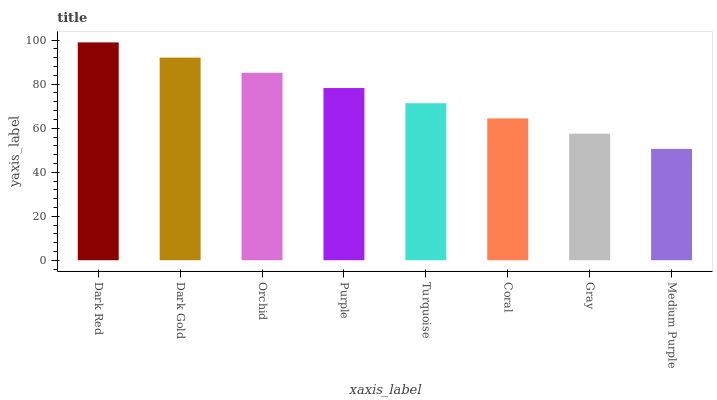Is Medium Purple the minimum?
Answer yes or no. Yes. Is Dark Red the maximum?
Answer yes or no. Yes. Is Dark Gold the minimum?
Answer yes or no. No. Is Dark Gold the maximum?
Answer yes or no. No. Is Dark Red greater than Dark Gold?
Answer yes or no. Yes. Is Dark Gold less than Dark Red?
Answer yes or no. Yes. Is Dark Gold greater than Dark Red?
Answer yes or no. No. Is Dark Red less than Dark Gold?
Answer yes or no. No. Is Purple the high median?
Answer yes or no. Yes. Is Turquoise the low median?
Answer yes or no. Yes. Is Orchid the high median?
Answer yes or no. No. Is Purple the low median?
Answer yes or no. No. 